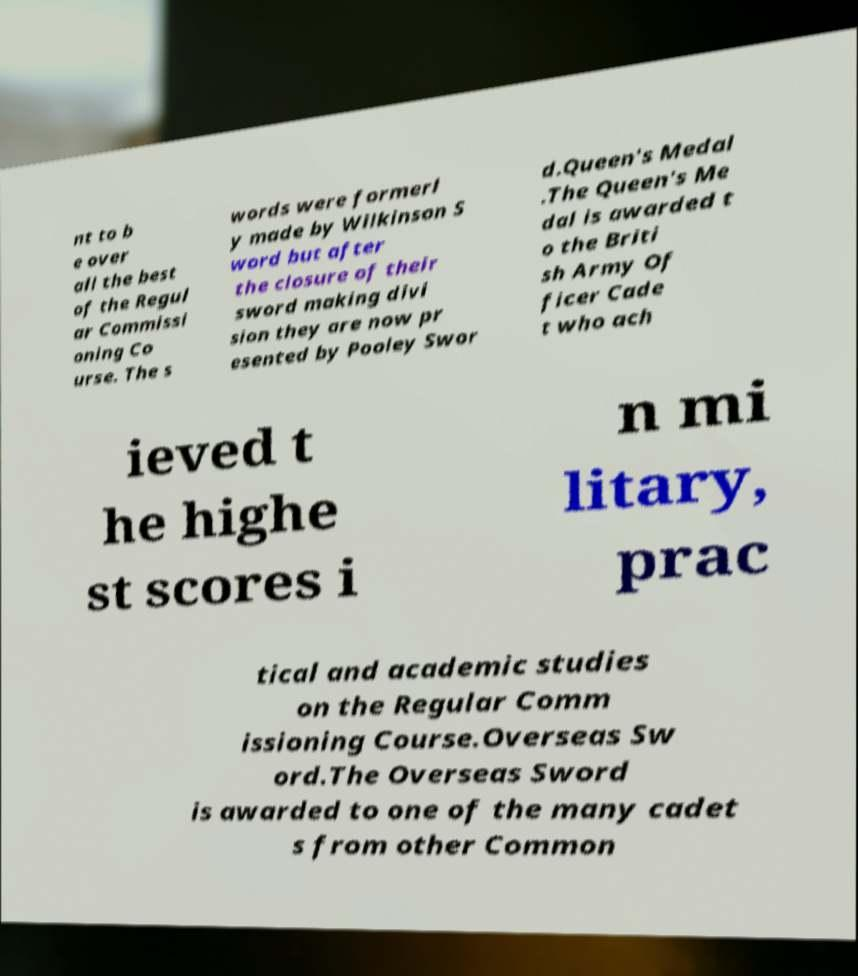Can you accurately transcribe the text from the provided image for me? nt to b e over all the best of the Regul ar Commissi oning Co urse. The s words were formerl y made by Wilkinson S word but after the closure of their sword making divi sion they are now pr esented by Pooley Swor d.Queen's Medal .The Queen's Me dal is awarded t o the Briti sh Army Of ficer Cade t who ach ieved t he highe st scores i n mi litary, prac tical and academic studies on the Regular Comm issioning Course.Overseas Sw ord.The Overseas Sword is awarded to one of the many cadet s from other Common 